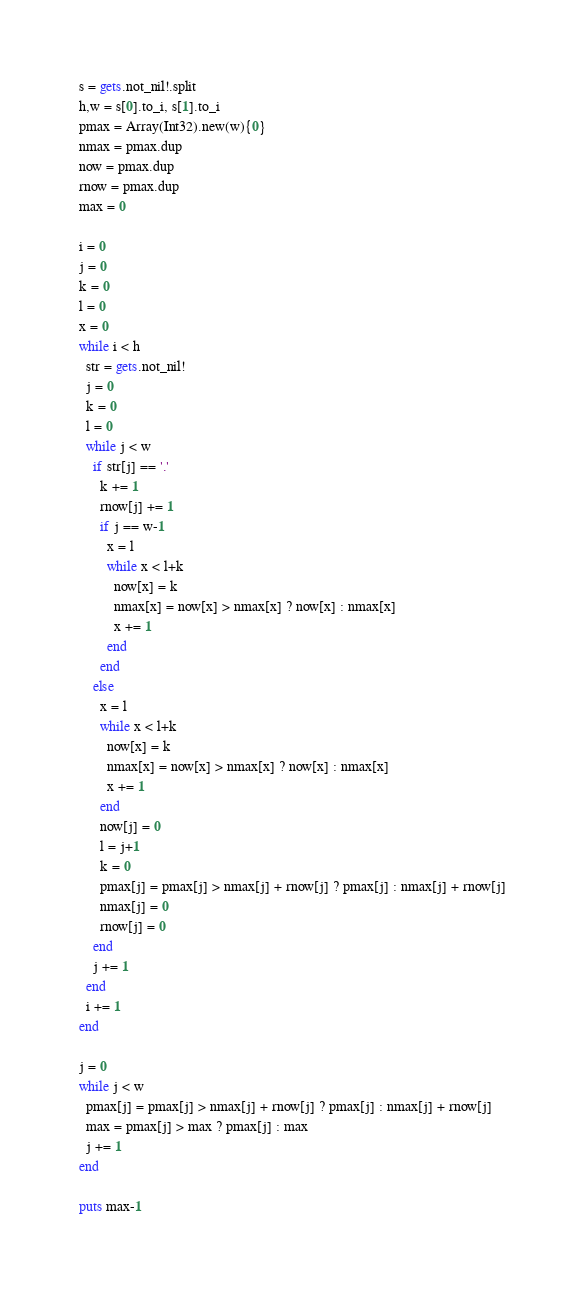<code> <loc_0><loc_0><loc_500><loc_500><_Crystal_>s = gets.not_nil!.split
h,w = s[0].to_i, s[1].to_i
pmax = Array(Int32).new(w){0}
nmax = pmax.dup
now = pmax.dup
rnow = pmax.dup
max = 0

i = 0
j = 0
k = 0
l = 0
x = 0
while i < h
  str = gets.not_nil!
  j = 0
  k = 0
  l = 0
  while j < w
    if str[j] == '.'
      k += 1
      rnow[j] += 1
      if j == w-1
        x = l
        while x < l+k
          now[x] = k
          nmax[x] = now[x] > nmax[x] ? now[x] : nmax[x]
          x += 1
        end
      end
    else
      x = l
      while x < l+k
        now[x] = k
        nmax[x] = now[x] > nmax[x] ? now[x] : nmax[x]
        x += 1
      end
      now[j] = 0
      l = j+1
      k = 0
      pmax[j] = pmax[j] > nmax[j] + rnow[j] ? pmax[j] : nmax[j] + rnow[j]
      nmax[j] = 0
      rnow[j] = 0
    end
    j += 1
  end
  i += 1
end

j = 0
while j < w
  pmax[j] = pmax[j] > nmax[j] + rnow[j] ? pmax[j] : nmax[j] + rnow[j]
  max = pmax[j] > max ? pmax[j] : max
  j += 1
end

puts max-1
</code> 